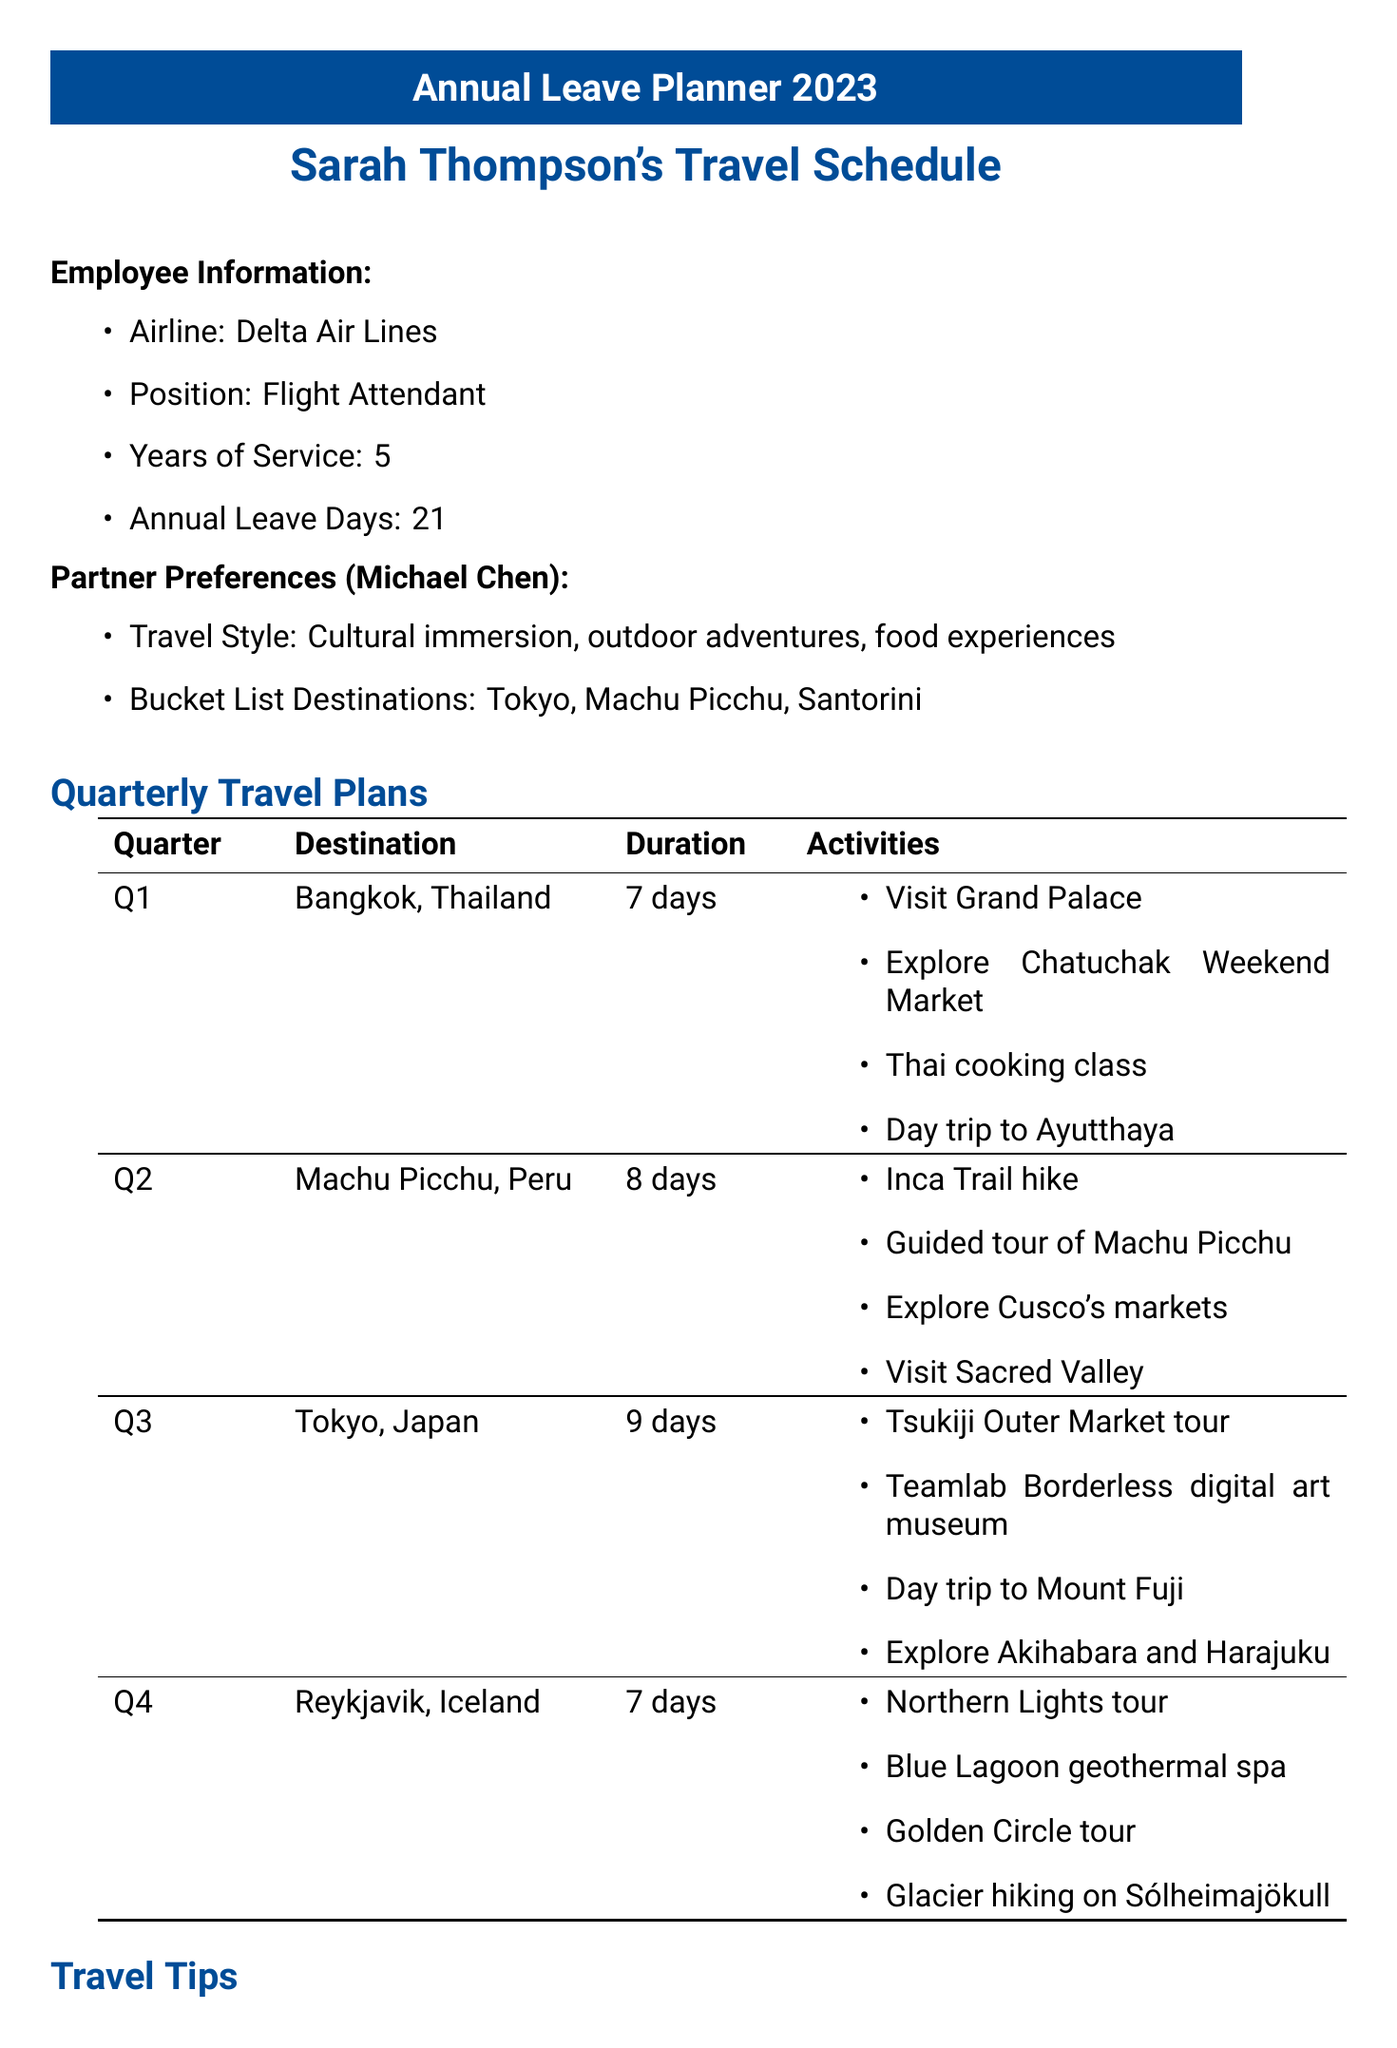What is the name of the employee? The document lists the employee's name as Sarah Thompson.
Answer: Sarah Thompson How many annual leave days does Sarah have? The total number of annual leave days available to the employee is stated as 21.
Answer: 21 Which destination has high flight availability in Q2? The document mentions that Rome, Italy has high flight availability in Q2.
Answer: Rome, Italy What is Michael's travel style? The document specifies Michael's travel style includes cultural immersion, outdoor adventures, and food experiences.
Answer: Cultural immersion, outdoor adventures, food experiences How long is the suggested trip to Santorini? The duration for the suggested trip to Santorini is mentioned as 6 days.
Answer: 6 days What are the two travel tips provided? The document includes several travel tips such as booking flights at least 3 months in advance and considering shoulder seasons to avoid crowds.
Answer: Book flights at least 3 months in advance, consider shoulder seasons Which two destinations from the quarterly plans are on Michael's bucket list? The document indicates that Tokyo and Machu Picchu are among Michael's bucket list destinations.
Answer: Tokyo, Machu Picchu How many activities are suggested for the trip to Bangkok? The document lists four activities for the trip to Bangkok.
Answer: Four What is a key budget consideration for dining? The document suggests balancing between local street food and fine dining experiences for dining.
Answer: Balance between local street food and fine dining experiences What must be checked regarding travel documents? The document states that visa requirements for each destination must be checked.
Answer: Check visa requirements 